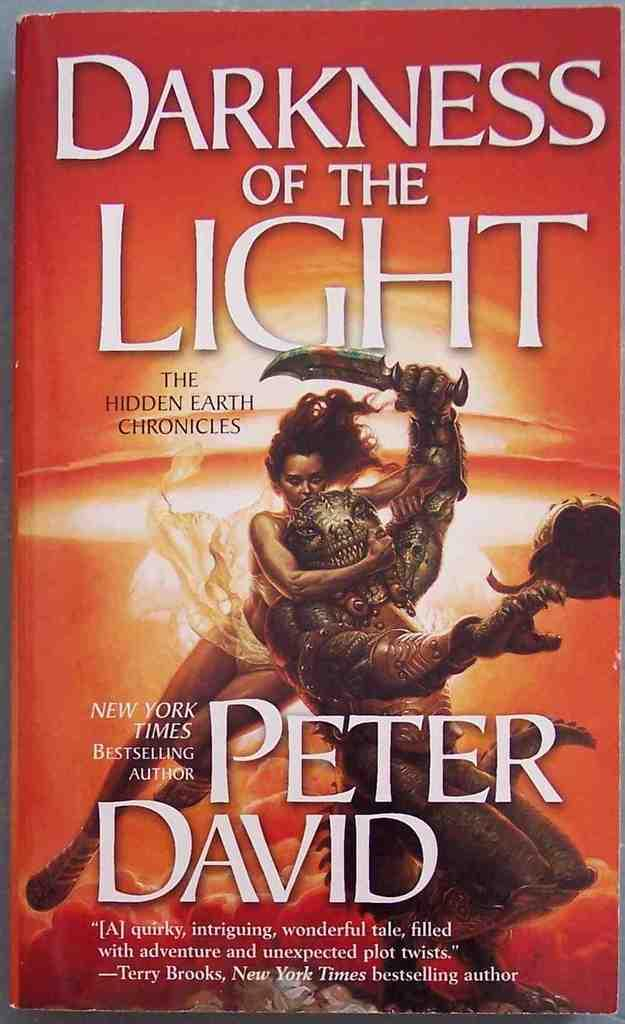<image>
Provide a brief description of the given image. Cover of a book with a women holding a knife named, "Darkness of the Light." 